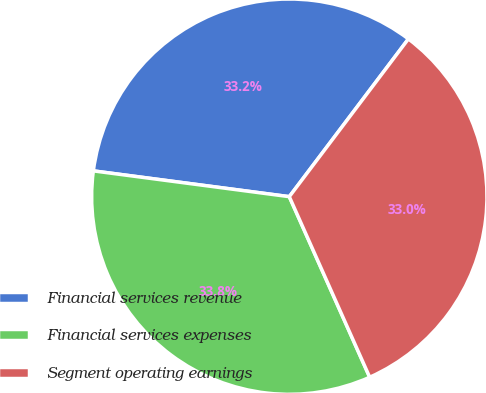Convert chart to OTSL. <chart><loc_0><loc_0><loc_500><loc_500><pie_chart><fcel>Financial services revenue<fcel>Financial services expenses<fcel>Segment operating earnings<nl><fcel>33.21%<fcel>33.75%<fcel>33.04%<nl></chart> 